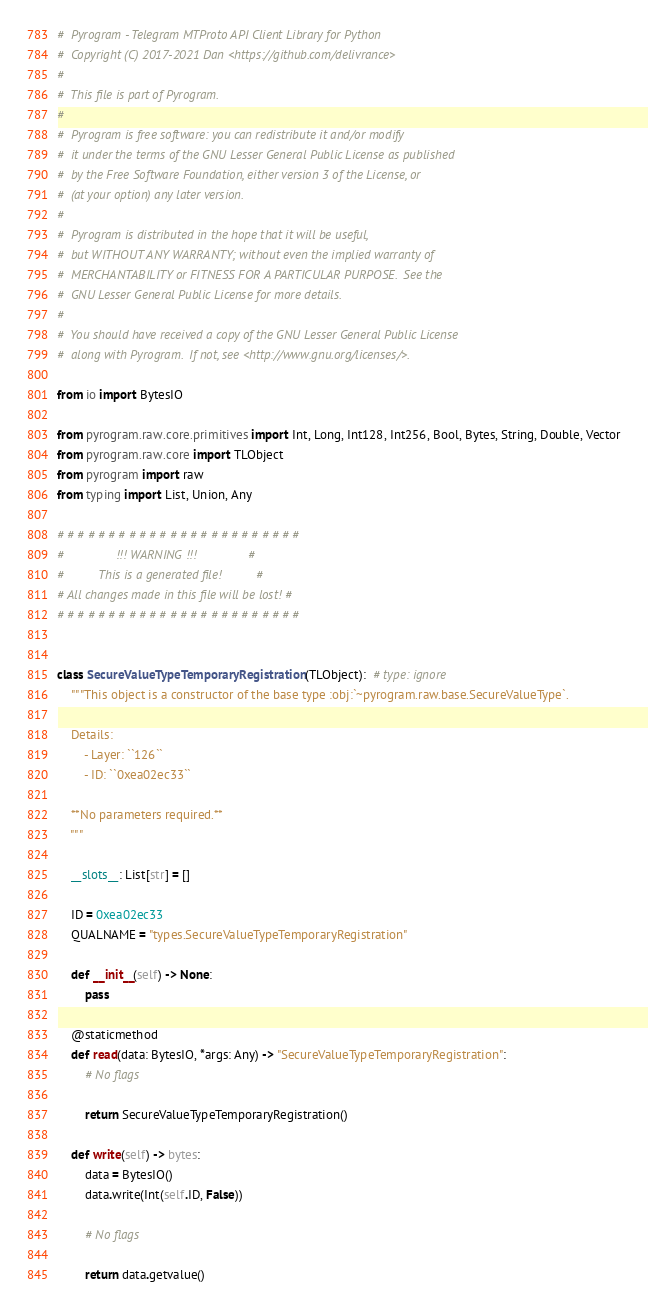Convert code to text. <code><loc_0><loc_0><loc_500><loc_500><_Python_>#  Pyrogram - Telegram MTProto API Client Library for Python
#  Copyright (C) 2017-2021 Dan <https://github.com/delivrance>
#
#  This file is part of Pyrogram.
#
#  Pyrogram is free software: you can redistribute it and/or modify
#  it under the terms of the GNU Lesser General Public License as published
#  by the Free Software Foundation, either version 3 of the License, or
#  (at your option) any later version.
#
#  Pyrogram is distributed in the hope that it will be useful,
#  but WITHOUT ANY WARRANTY; without even the implied warranty of
#  MERCHANTABILITY or FITNESS FOR A PARTICULAR PURPOSE.  See the
#  GNU Lesser General Public License for more details.
#
#  You should have received a copy of the GNU Lesser General Public License
#  along with Pyrogram.  If not, see <http://www.gnu.org/licenses/>.

from io import BytesIO

from pyrogram.raw.core.primitives import Int, Long, Int128, Int256, Bool, Bytes, String, Double, Vector
from pyrogram.raw.core import TLObject
from pyrogram import raw
from typing import List, Union, Any

# # # # # # # # # # # # # # # # # # # # # # # #
#               !!! WARNING !!!               #
#          This is a generated file!          #
# All changes made in this file will be lost! #
# # # # # # # # # # # # # # # # # # # # # # # #


class SecureValueTypeTemporaryRegistration(TLObject):  # type: ignore
    """This object is a constructor of the base type :obj:`~pyrogram.raw.base.SecureValueType`.

    Details:
        - Layer: ``126``
        - ID: ``0xea02ec33``

    **No parameters required.**
    """

    __slots__: List[str] = []

    ID = 0xea02ec33
    QUALNAME = "types.SecureValueTypeTemporaryRegistration"

    def __init__(self) -> None:
        pass

    @staticmethod
    def read(data: BytesIO, *args: Any) -> "SecureValueTypeTemporaryRegistration":
        # No flags
        
        return SecureValueTypeTemporaryRegistration()

    def write(self) -> bytes:
        data = BytesIO()
        data.write(Int(self.ID, False))

        # No flags
        
        return data.getvalue()
</code> 